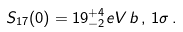<formula> <loc_0><loc_0><loc_500><loc_500>S _ { 1 7 } ( 0 ) = 1 9 ^ { + 4 } _ { - 2 } e V \, b \, , \, 1 \sigma \, .</formula> 